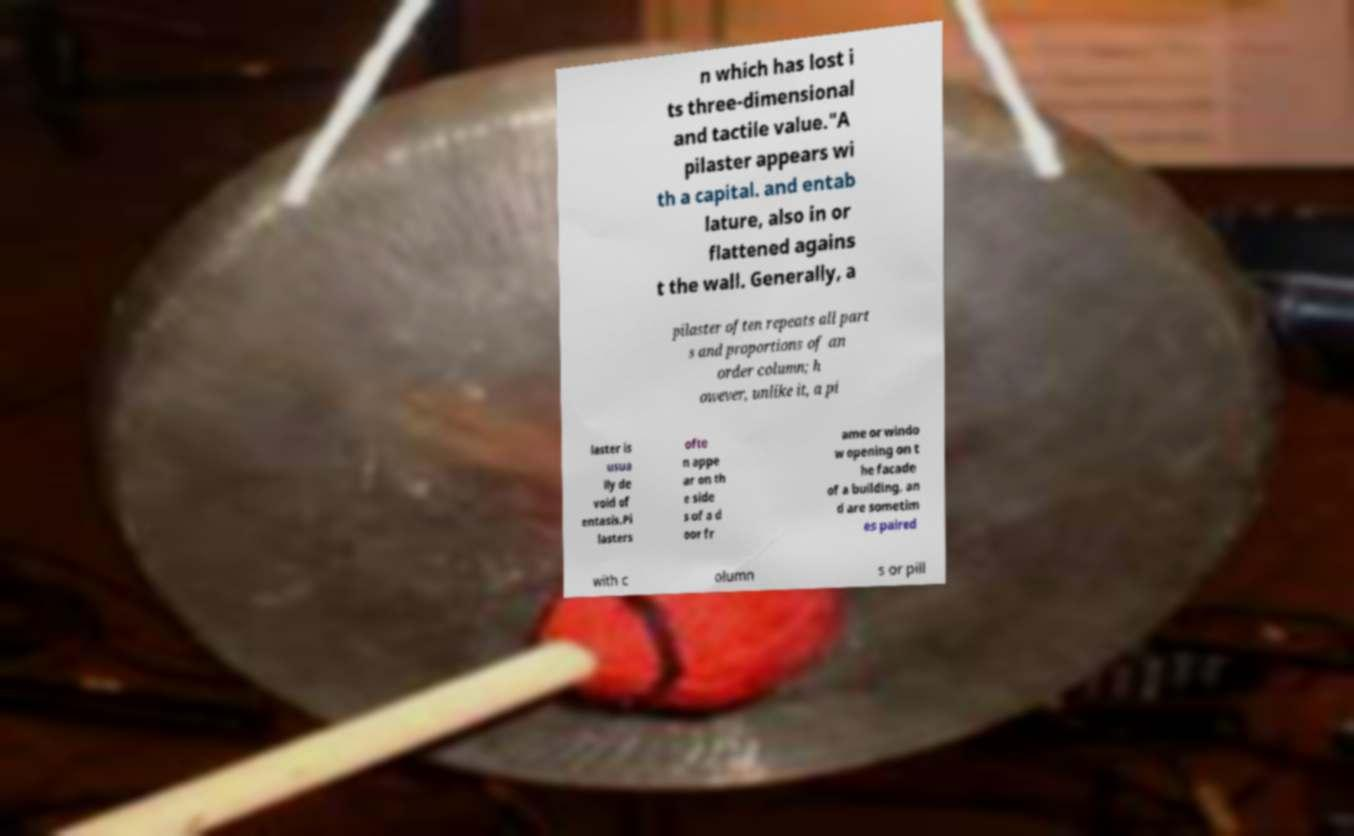Can you accurately transcribe the text from the provided image for me? n which has lost i ts three-dimensional and tactile value."A pilaster appears wi th a capital. and entab lature, also in or flattened agains t the wall. Generally, a pilaster often repeats all part s and proportions of an order column; h owever, unlike it, a pi laster is usua lly de void of entasis.Pi lasters ofte n appe ar on th e side s of a d oor fr ame or windo w opening on t he facade of a building, an d are sometim es paired with c olumn s or pill 